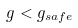Convert formula to latex. <formula><loc_0><loc_0><loc_500><loc_500>g < g _ { s a f e }</formula> 